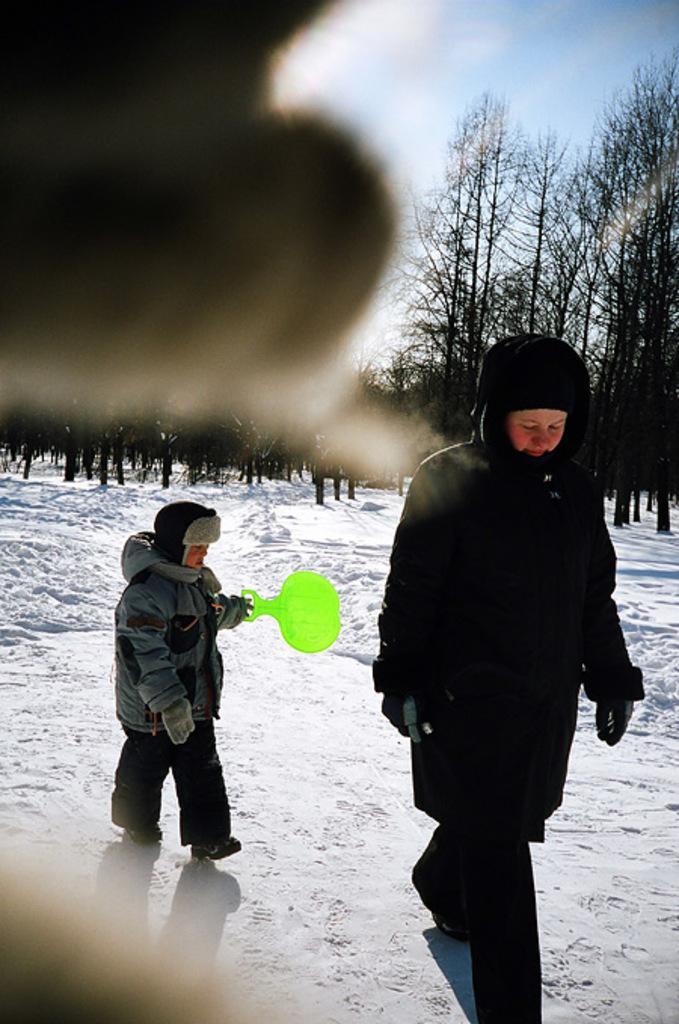Could you give a brief overview of what you see in this image? In the foreground of this image, the object is blurred. In the background, there is a person walking on the snow and a boy holding a green racket and walking on the snow and there are trees, sky and the cloud. 